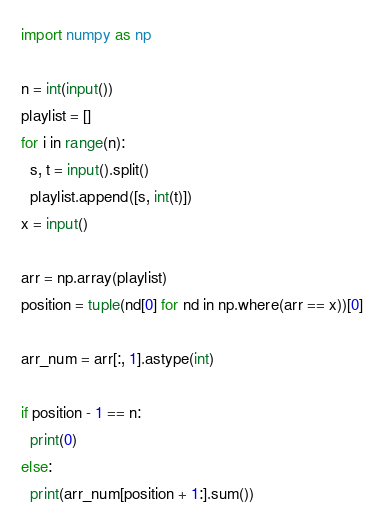Convert code to text. <code><loc_0><loc_0><loc_500><loc_500><_Python_>import numpy as np

n = int(input())
playlist = []
for i in range(n):
  s, t = input().split()
  playlist.append([s, int(t)])
x = input()

arr = np.array(playlist)
position = tuple(nd[0] for nd in np.where(arr == x))[0]

arr_num = arr[:, 1].astype(int)

if position - 1 == n:
  print(0)
else:
  print(arr_num[position + 1:].sum())
</code> 